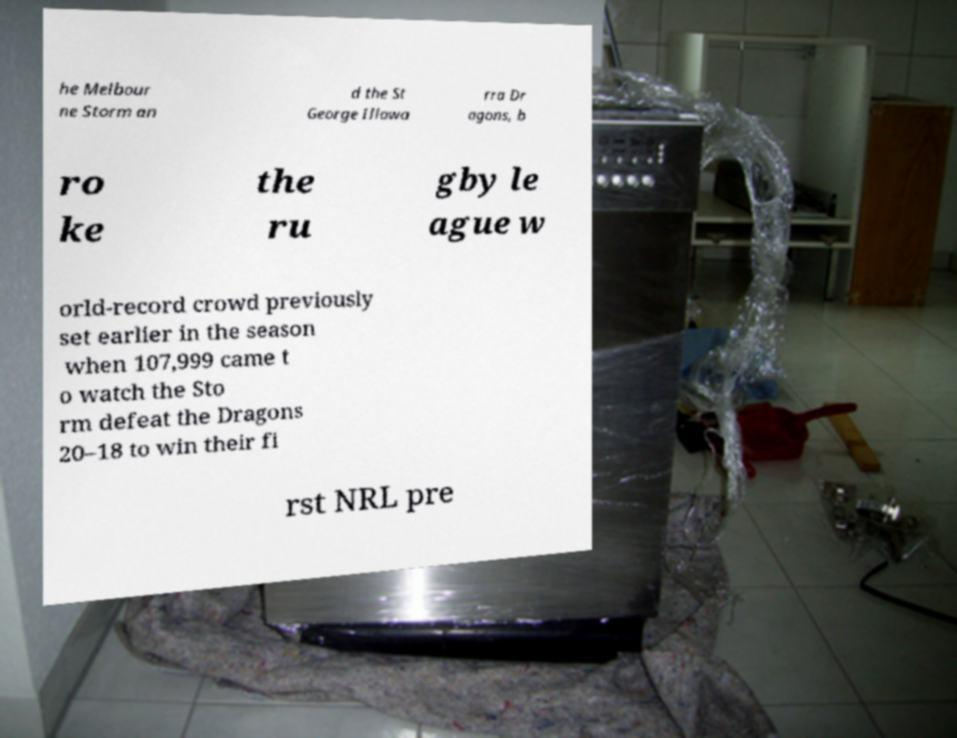Could you assist in decoding the text presented in this image and type it out clearly? he Melbour ne Storm an d the St George Illawa rra Dr agons, b ro ke the ru gby le ague w orld-record crowd previously set earlier in the season when 107,999 came t o watch the Sto rm defeat the Dragons 20–18 to win their fi rst NRL pre 